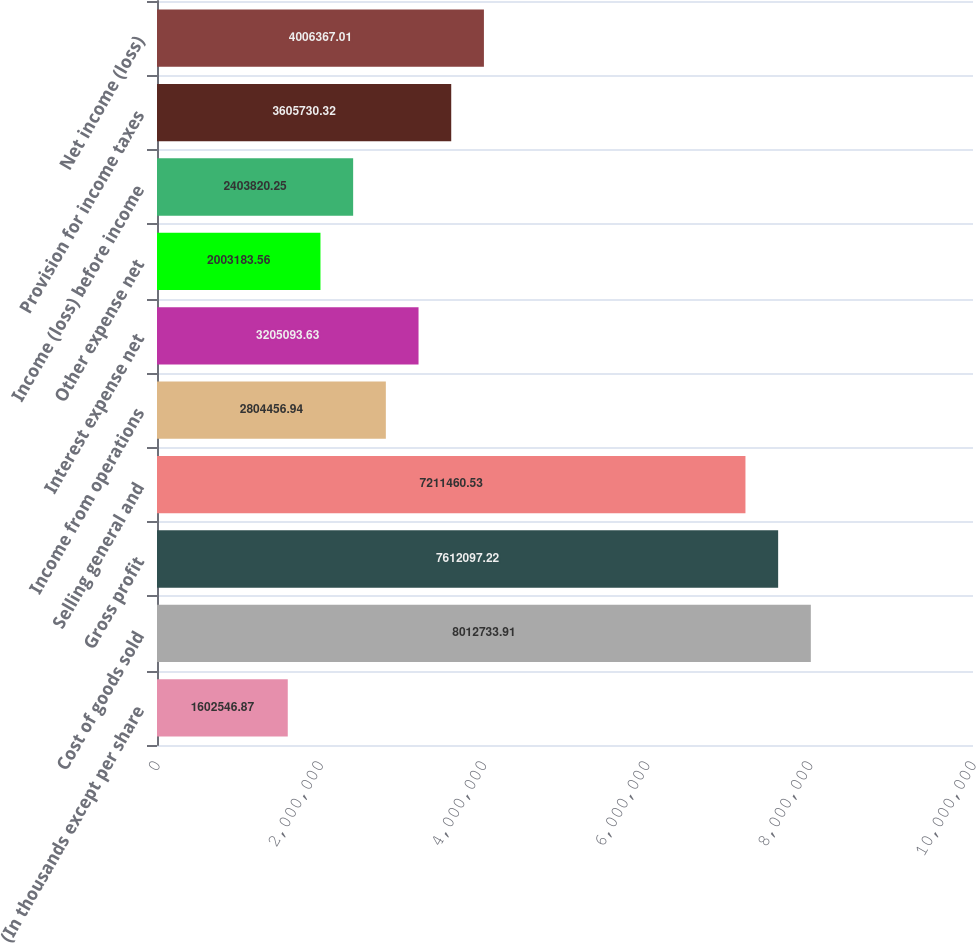Convert chart to OTSL. <chart><loc_0><loc_0><loc_500><loc_500><bar_chart><fcel>(In thousands except per share<fcel>Cost of goods sold<fcel>Gross profit<fcel>Selling general and<fcel>Income from operations<fcel>Interest expense net<fcel>Other expense net<fcel>Income (loss) before income<fcel>Provision for income taxes<fcel>Net income (loss)<nl><fcel>1.60255e+06<fcel>8.01273e+06<fcel>7.6121e+06<fcel>7.21146e+06<fcel>2.80446e+06<fcel>3.20509e+06<fcel>2.00318e+06<fcel>2.40382e+06<fcel>3.60573e+06<fcel>4.00637e+06<nl></chart> 